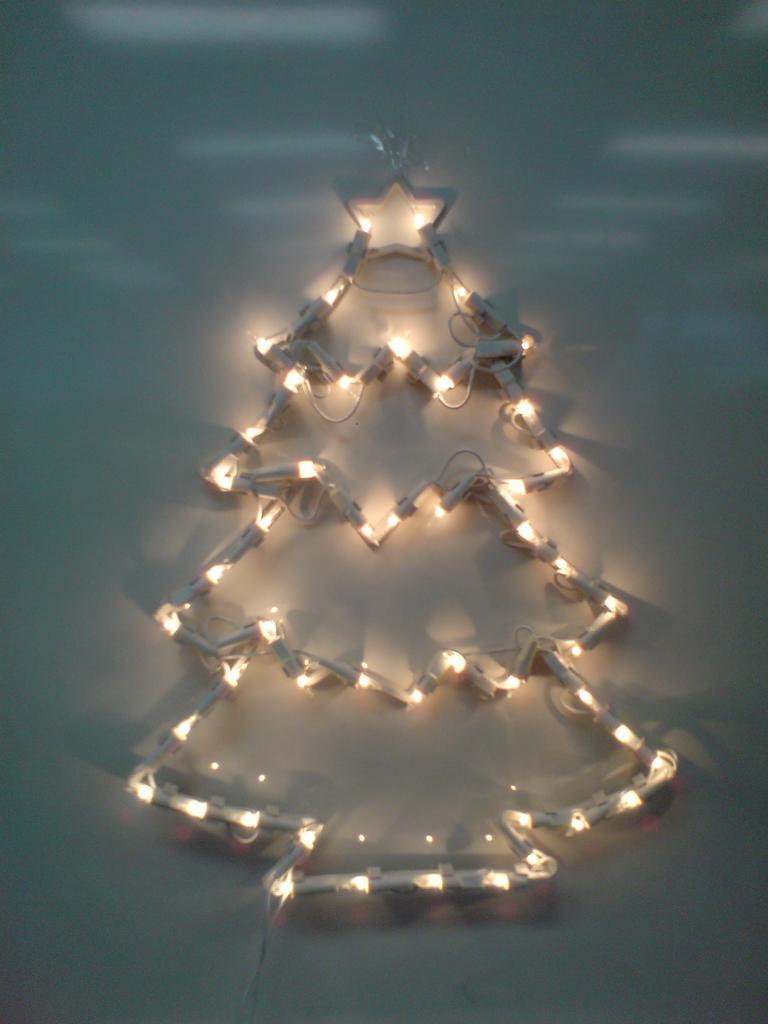In one or two sentences, can you explain what this image depicts? In this picture we can see lights. These lights are in the form of a tree. 